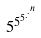<formula> <loc_0><loc_0><loc_500><loc_500>5 ^ { 5 ^ { 5 ^ { . ^ { . ^ { n } } } } }</formula> 